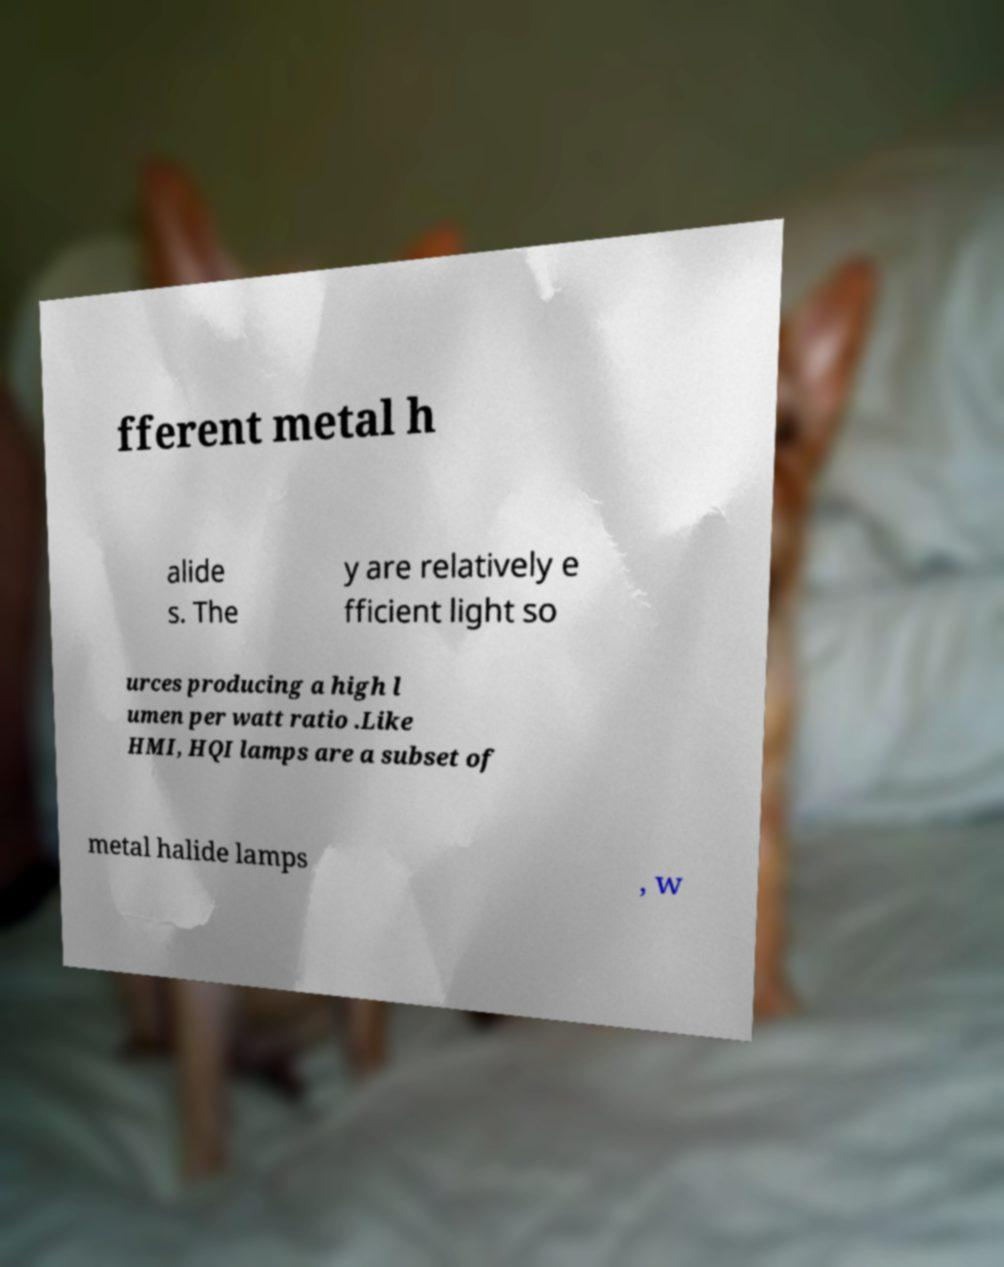Can you accurately transcribe the text from the provided image for me? fferent metal h alide s. The y are relatively e fficient light so urces producing a high l umen per watt ratio .Like HMI, HQI lamps are a subset of metal halide lamps , w 